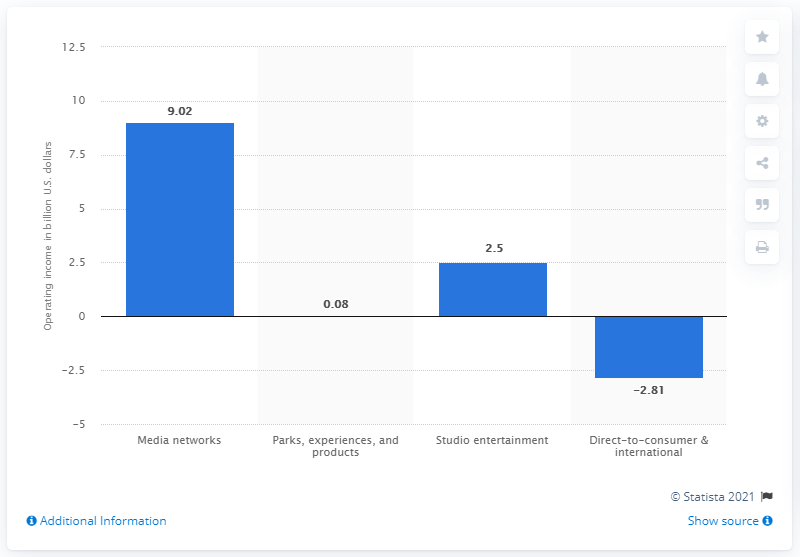Identify some key points in this picture. The Walt Disney Company earned a significant amount of money with its media network in 2020, totaling 9.02... 